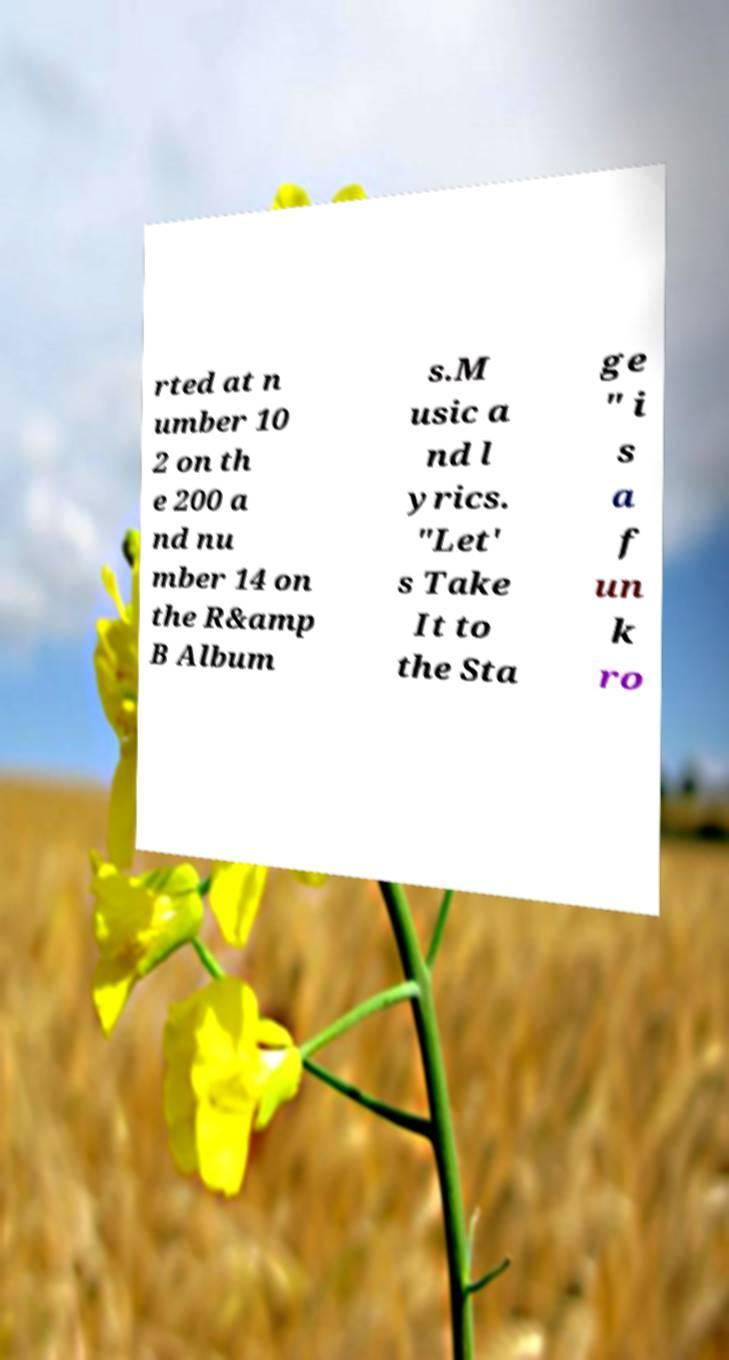Could you assist in decoding the text presented in this image and type it out clearly? rted at n umber 10 2 on th e 200 a nd nu mber 14 on the R&amp B Album s.M usic a nd l yrics. "Let' s Take It to the Sta ge " i s a f un k ro 